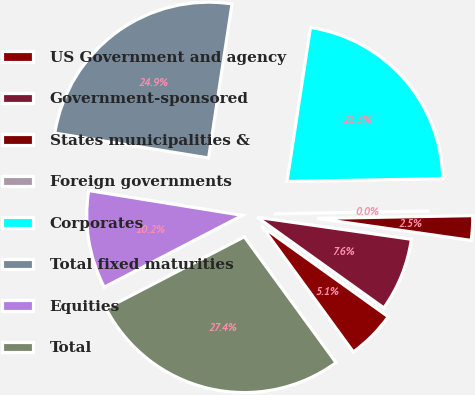Convert chart. <chart><loc_0><loc_0><loc_500><loc_500><pie_chart><fcel>US Government and agency<fcel>Government-sponsored<fcel>States municipalities &<fcel>Foreign governments<fcel>Corporates<fcel>Total fixed maturities<fcel>Equities<fcel>Total<nl><fcel>5.09%<fcel>7.63%<fcel>2.54%<fcel>0.0%<fcel>22.31%<fcel>24.85%<fcel>10.17%<fcel>27.4%<nl></chart> 